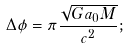<formula> <loc_0><loc_0><loc_500><loc_500>\Delta \phi = \pi \frac { \sqrt { G a _ { 0 } M } } { c ^ { 2 } } ;</formula> 